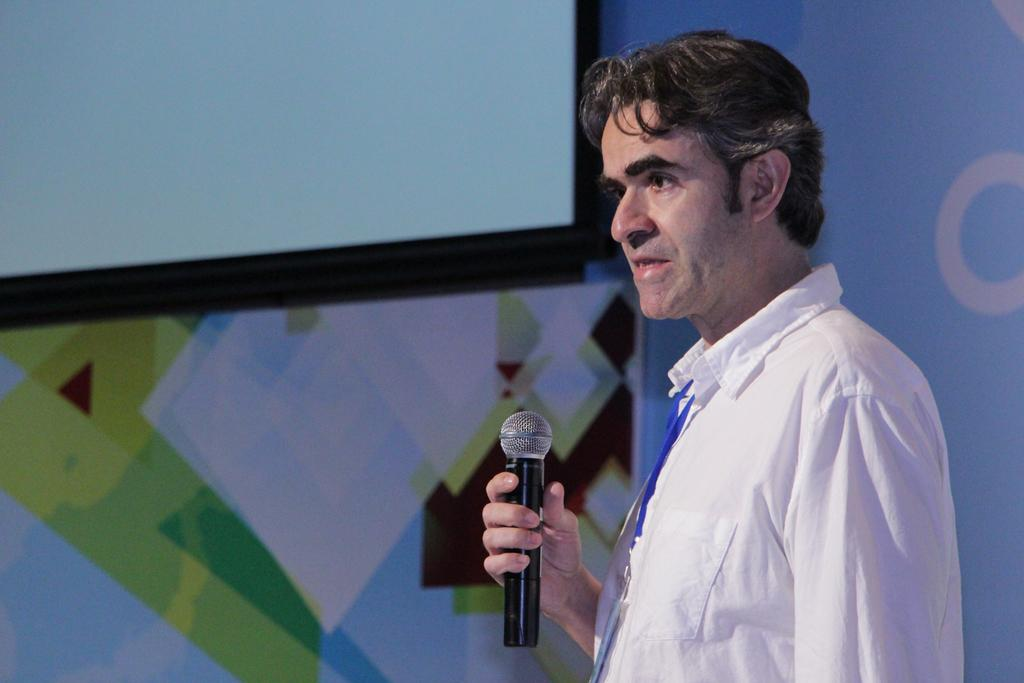What is the man in the image doing? The man is standing in the image and speaking. What is the man holding in his hand? The man is holding a microphone in his hand. What can be seen in the background of the image? There is a wall and a projector screen in the background of the image. What type of bear can be seen sitting on the cushion in the image? There is no bear or cushion present in the image. Is there a mailbox visible in the image? No, there is no mailbox visible in the image. 